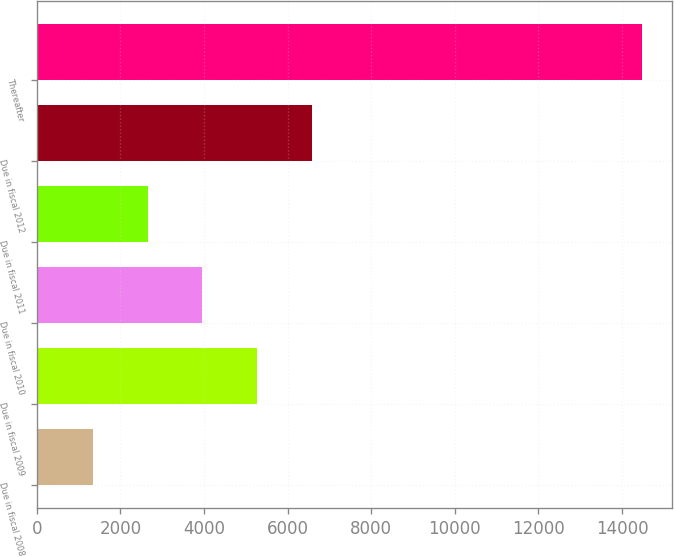<chart> <loc_0><loc_0><loc_500><loc_500><bar_chart><fcel>Due in fiscal 2008<fcel>Due in fiscal 2009<fcel>Due in fiscal 2010<fcel>Due in fiscal 2011<fcel>Due in fiscal 2012<fcel>Thereafter<nl><fcel>1339<fcel>5277.4<fcel>3964.6<fcel>2651.8<fcel>6590.2<fcel>14467<nl></chart> 